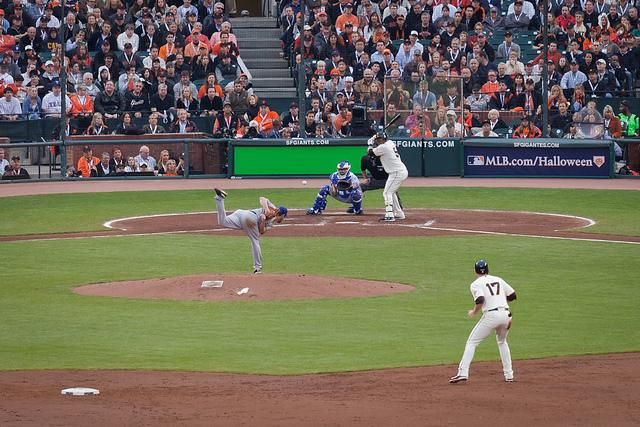What is the man on one leg doing?

Choices:
A) singing
B) hopping
C) pitching
D) hiding pitching 